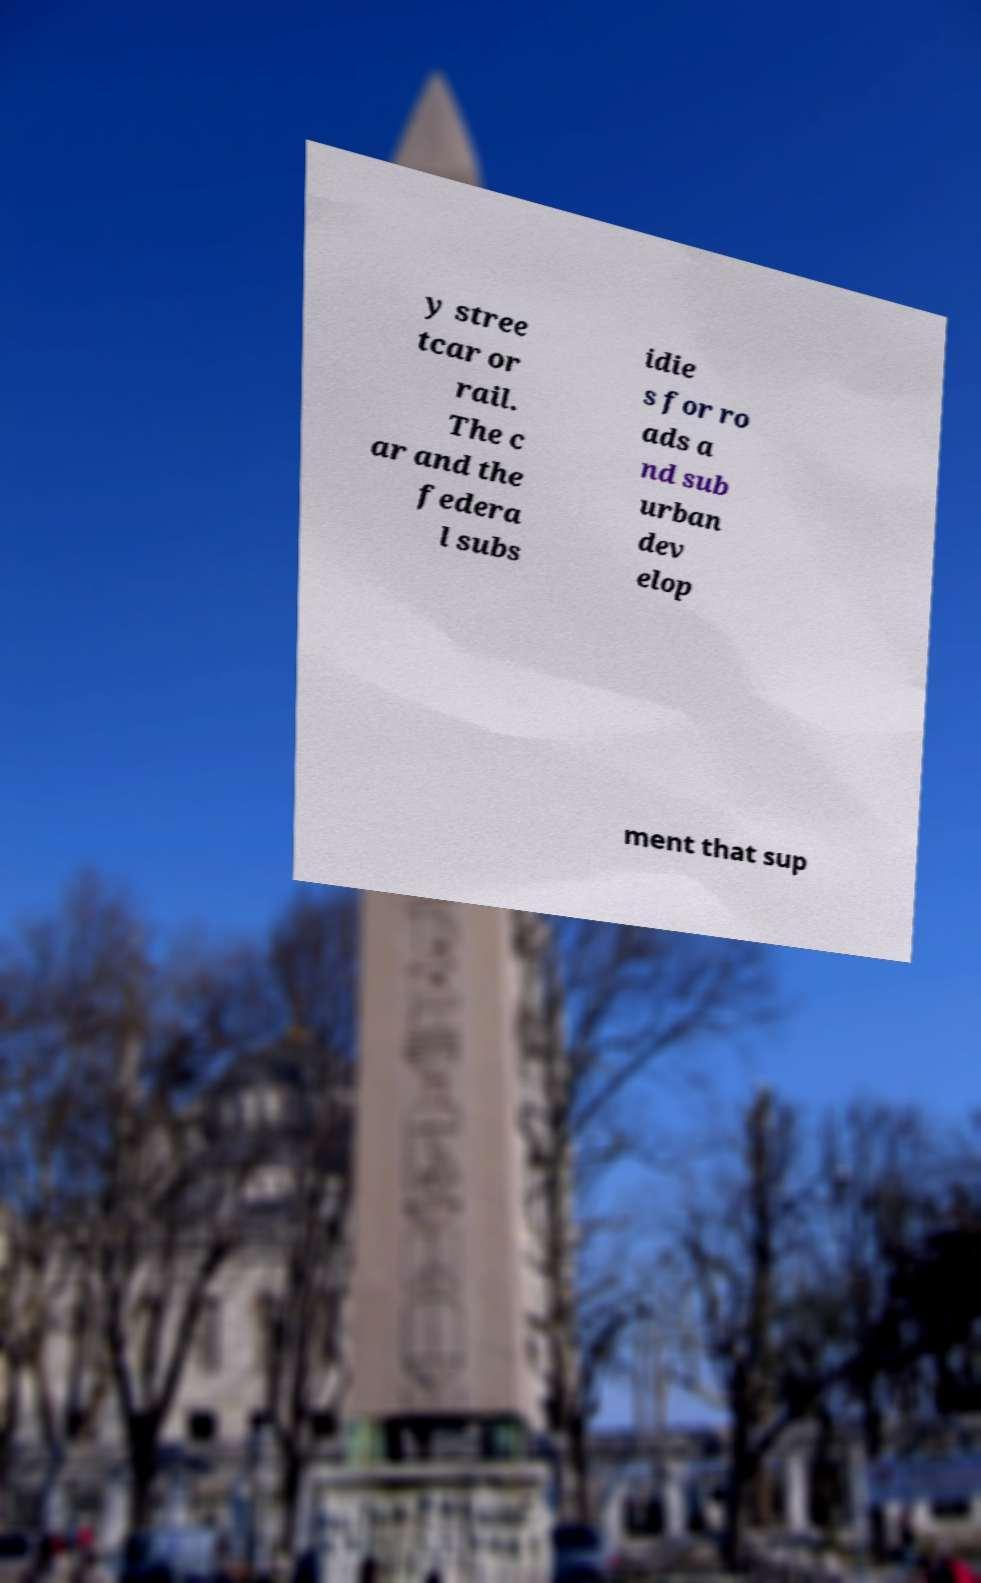Could you assist in decoding the text presented in this image and type it out clearly? y stree tcar or rail. The c ar and the federa l subs idie s for ro ads a nd sub urban dev elop ment that sup 